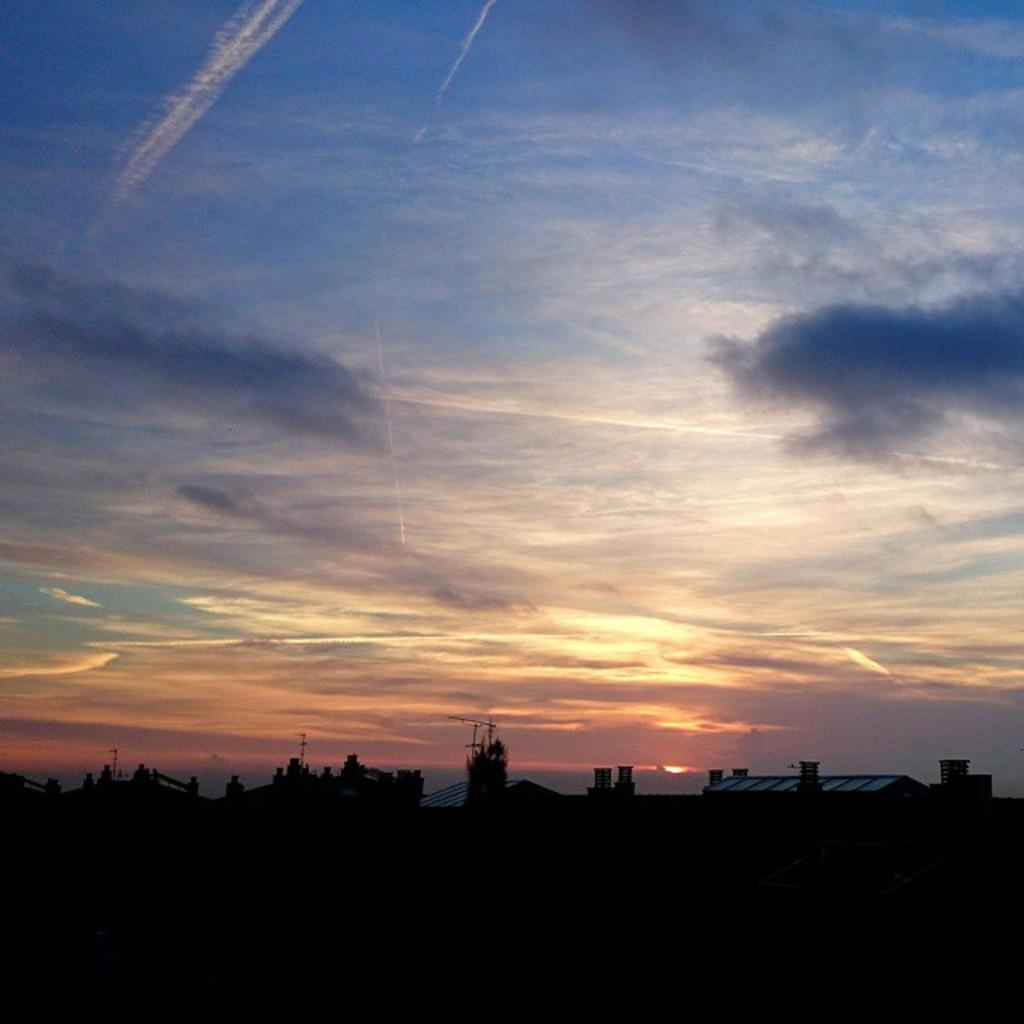What color is the sky in the image? The sky in the image is blue. What is covering the blue sky in the image? The sky is covered with clouds. What type of structures can be seen in the image? There are buildings in the image. What are the vertical structures in the image? There are poles in the image. Where is the doctor treating a patient inside a tent in the image? There is no doctor, patient, or tent present in the image. 